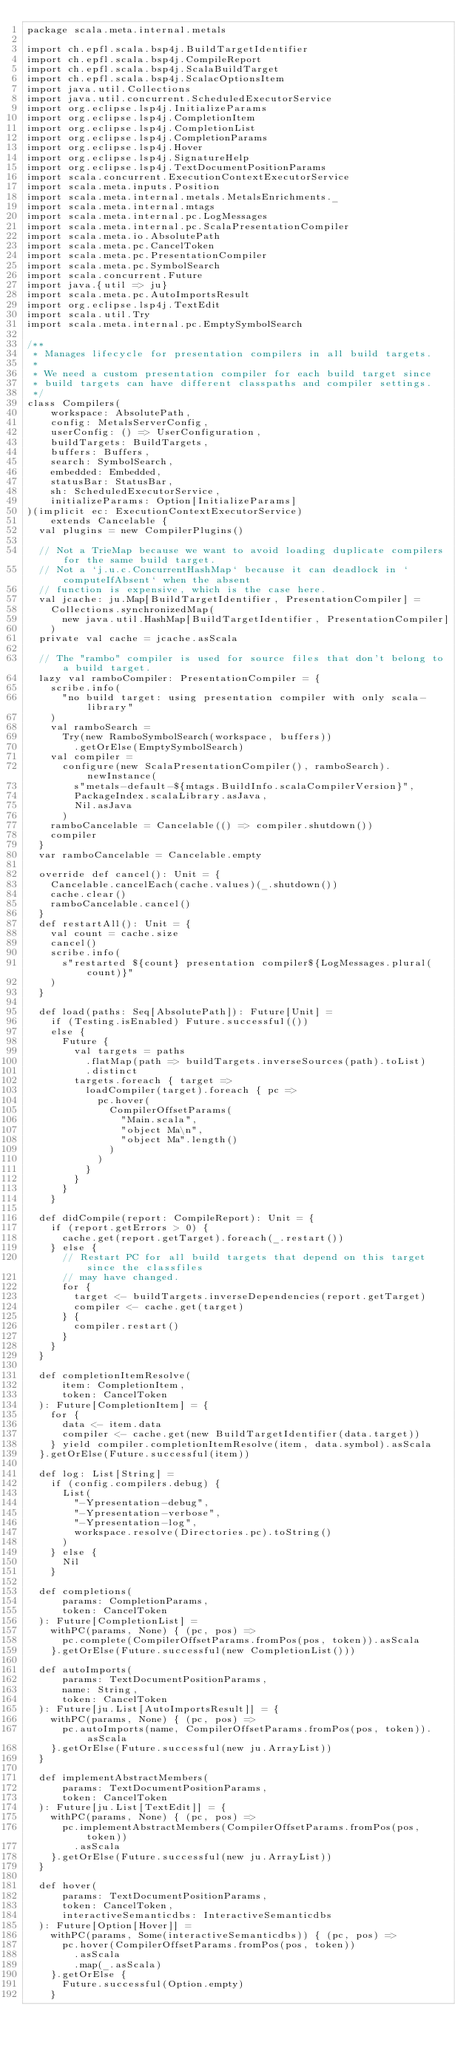<code> <loc_0><loc_0><loc_500><loc_500><_Scala_>package scala.meta.internal.metals

import ch.epfl.scala.bsp4j.BuildTargetIdentifier
import ch.epfl.scala.bsp4j.CompileReport
import ch.epfl.scala.bsp4j.ScalaBuildTarget
import ch.epfl.scala.bsp4j.ScalacOptionsItem
import java.util.Collections
import java.util.concurrent.ScheduledExecutorService
import org.eclipse.lsp4j.InitializeParams
import org.eclipse.lsp4j.CompletionItem
import org.eclipse.lsp4j.CompletionList
import org.eclipse.lsp4j.CompletionParams
import org.eclipse.lsp4j.Hover
import org.eclipse.lsp4j.SignatureHelp
import org.eclipse.lsp4j.TextDocumentPositionParams
import scala.concurrent.ExecutionContextExecutorService
import scala.meta.inputs.Position
import scala.meta.internal.metals.MetalsEnrichments._
import scala.meta.internal.mtags
import scala.meta.internal.pc.LogMessages
import scala.meta.internal.pc.ScalaPresentationCompiler
import scala.meta.io.AbsolutePath
import scala.meta.pc.CancelToken
import scala.meta.pc.PresentationCompiler
import scala.meta.pc.SymbolSearch
import scala.concurrent.Future
import java.{util => ju}
import scala.meta.pc.AutoImportsResult
import org.eclipse.lsp4j.TextEdit
import scala.util.Try
import scala.meta.internal.pc.EmptySymbolSearch

/**
 * Manages lifecycle for presentation compilers in all build targets.
 *
 * We need a custom presentation compiler for each build target since
 * build targets can have different classpaths and compiler settings.
 */
class Compilers(
    workspace: AbsolutePath,
    config: MetalsServerConfig,
    userConfig: () => UserConfiguration,
    buildTargets: BuildTargets,
    buffers: Buffers,
    search: SymbolSearch,
    embedded: Embedded,
    statusBar: StatusBar,
    sh: ScheduledExecutorService,
    initializeParams: Option[InitializeParams]
)(implicit ec: ExecutionContextExecutorService)
    extends Cancelable {
  val plugins = new CompilerPlugins()

  // Not a TrieMap because we want to avoid loading duplicate compilers for the same build target.
  // Not a `j.u.c.ConcurrentHashMap` because it can deadlock in `computeIfAbsent` when the absent
  // function is expensive, which is the case here.
  val jcache: ju.Map[BuildTargetIdentifier, PresentationCompiler] =
    Collections.synchronizedMap(
      new java.util.HashMap[BuildTargetIdentifier, PresentationCompiler]
    )
  private val cache = jcache.asScala

  // The "rambo" compiler is used for source files that don't belong to a build target.
  lazy val ramboCompiler: PresentationCompiler = {
    scribe.info(
      "no build target: using presentation compiler with only scala-library"
    )
    val ramboSearch =
      Try(new RamboSymbolSearch(workspace, buffers))
        .getOrElse(EmptySymbolSearch)
    val compiler =
      configure(new ScalaPresentationCompiler(), ramboSearch).newInstance(
        s"metals-default-${mtags.BuildInfo.scalaCompilerVersion}",
        PackageIndex.scalaLibrary.asJava,
        Nil.asJava
      )
    ramboCancelable = Cancelable(() => compiler.shutdown())
    compiler
  }
  var ramboCancelable = Cancelable.empty

  override def cancel(): Unit = {
    Cancelable.cancelEach(cache.values)(_.shutdown())
    cache.clear()
    ramboCancelable.cancel()
  }
  def restartAll(): Unit = {
    val count = cache.size
    cancel()
    scribe.info(
      s"restarted ${count} presentation compiler${LogMessages.plural(count)}"
    )
  }

  def load(paths: Seq[AbsolutePath]): Future[Unit] =
    if (Testing.isEnabled) Future.successful(())
    else {
      Future {
        val targets = paths
          .flatMap(path => buildTargets.inverseSources(path).toList)
          .distinct
        targets.foreach { target =>
          loadCompiler(target).foreach { pc =>
            pc.hover(
              CompilerOffsetParams(
                "Main.scala",
                "object Ma\n",
                "object Ma".length()
              )
            )
          }
        }
      }
    }

  def didCompile(report: CompileReport): Unit = {
    if (report.getErrors > 0) {
      cache.get(report.getTarget).foreach(_.restart())
    } else {
      // Restart PC for all build targets that depend on this target since the classfiles
      // may have changed.
      for {
        target <- buildTargets.inverseDependencies(report.getTarget)
        compiler <- cache.get(target)
      } {
        compiler.restart()
      }
    }
  }

  def completionItemResolve(
      item: CompletionItem,
      token: CancelToken
  ): Future[CompletionItem] = {
    for {
      data <- item.data
      compiler <- cache.get(new BuildTargetIdentifier(data.target))
    } yield compiler.completionItemResolve(item, data.symbol).asScala
  }.getOrElse(Future.successful(item))

  def log: List[String] =
    if (config.compilers.debug) {
      List(
        "-Ypresentation-debug",
        "-Ypresentation-verbose",
        "-Ypresentation-log",
        workspace.resolve(Directories.pc).toString()
      )
    } else {
      Nil
    }

  def completions(
      params: CompletionParams,
      token: CancelToken
  ): Future[CompletionList] =
    withPC(params, None) { (pc, pos) =>
      pc.complete(CompilerOffsetParams.fromPos(pos, token)).asScala
    }.getOrElse(Future.successful(new CompletionList()))

  def autoImports(
      params: TextDocumentPositionParams,
      name: String,
      token: CancelToken
  ): Future[ju.List[AutoImportsResult]] = {
    withPC(params, None) { (pc, pos) =>
      pc.autoImports(name, CompilerOffsetParams.fromPos(pos, token)).asScala
    }.getOrElse(Future.successful(new ju.ArrayList))
  }

  def implementAbstractMembers(
      params: TextDocumentPositionParams,
      token: CancelToken
  ): Future[ju.List[TextEdit]] = {
    withPC(params, None) { (pc, pos) =>
      pc.implementAbstractMembers(CompilerOffsetParams.fromPos(pos, token))
        .asScala
    }.getOrElse(Future.successful(new ju.ArrayList))
  }

  def hover(
      params: TextDocumentPositionParams,
      token: CancelToken,
      interactiveSemanticdbs: InteractiveSemanticdbs
  ): Future[Option[Hover]] =
    withPC(params, Some(interactiveSemanticdbs)) { (pc, pos) =>
      pc.hover(CompilerOffsetParams.fromPos(pos, token))
        .asScala
        .map(_.asScala)
    }.getOrElse {
      Future.successful(Option.empty)
    }
</code> 